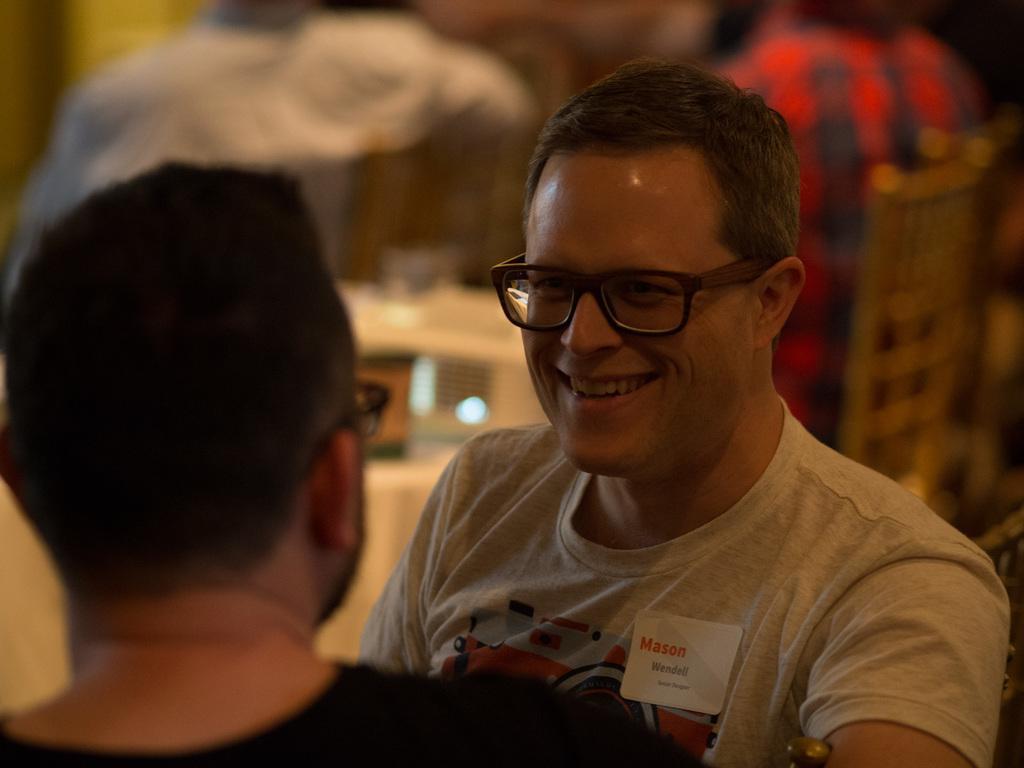Could you give a brief overview of what you see in this image? In this image I can see two persons, the person in front wearing white color shirt, and the other person is wearing black color shirt. Background I can see few other people sitting. 